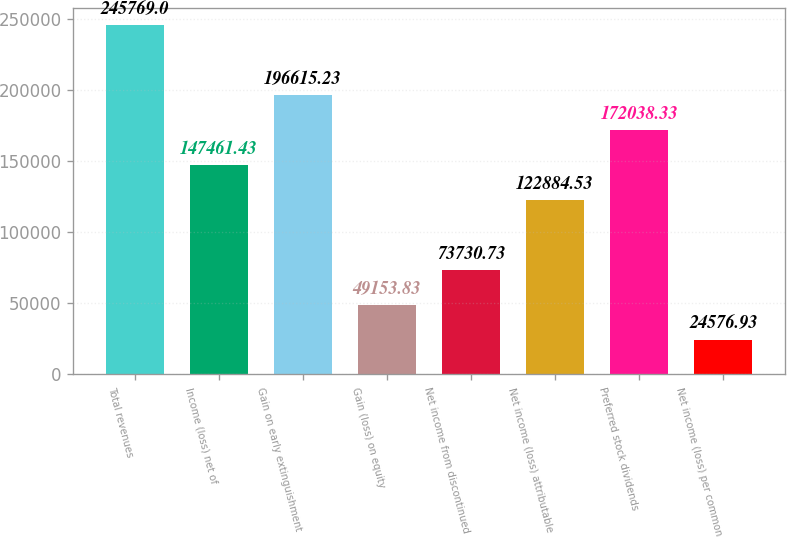Convert chart to OTSL. <chart><loc_0><loc_0><loc_500><loc_500><bar_chart><fcel>Total revenues<fcel>Income (loss) net of<fcel>Gain on early extinguishment<fcel>Gain (loss) on equity<fcel>Net income from discontinued<fcel>Net income (loss) attributable<fcel>Preferred stock dividends<fcel>Net income (loss) per common<nl><fcel>245769<fcel>147461<fcel>196615<fcel>49153.8<fcel>73730.7<fcel>122885<fcel>172038<fcel>24576.9<nl></chart> 